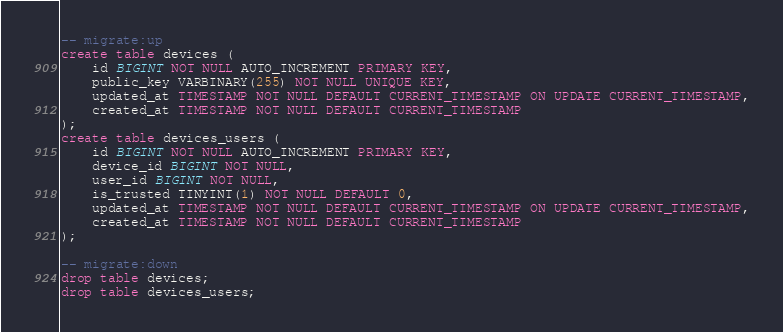Convert code to text. <code><loc_0><loc_0><loc_500><loc_500><_SQL_>-- migrate:up
create table devices (
    id BIGINT NOT NULL AUTO_INCREMENT PRIMARY KEY,
    public_key VARBINARY(255) NOT NULL UNIQUE KEY,
    updated_at TIMESTAMP NOT NULL DEFAULT CURRENT_TIMESTAMP ON UPDATE CURRENT_TIMESTAMP,
    created_at TIMESTAMP NOT NULL DEFAULT CURRENT_TIMESTAMP
);
create table devices_users (
    id BIGINT NOT NULL AUTO_INCREMENT PRIMARY KEY,
    device_id BIGINT NOT NULL,
    user_id BIGINT NOT NULL,
    is_trusted TINYINT(1) NOT NULL DEFAULT 0,
    updated_at TIMESTAMP NOT NULL DEFAULT CURRENT_TIMESTAMP ON UPDATE CURRENT_TIMESTAMP,
    created_at TIMESTAMP NOT NULL DEFAULT CURRENT_TIMESTAMP
);

-- migrate:down
drop table devices;
drop table devices_users;</code> 